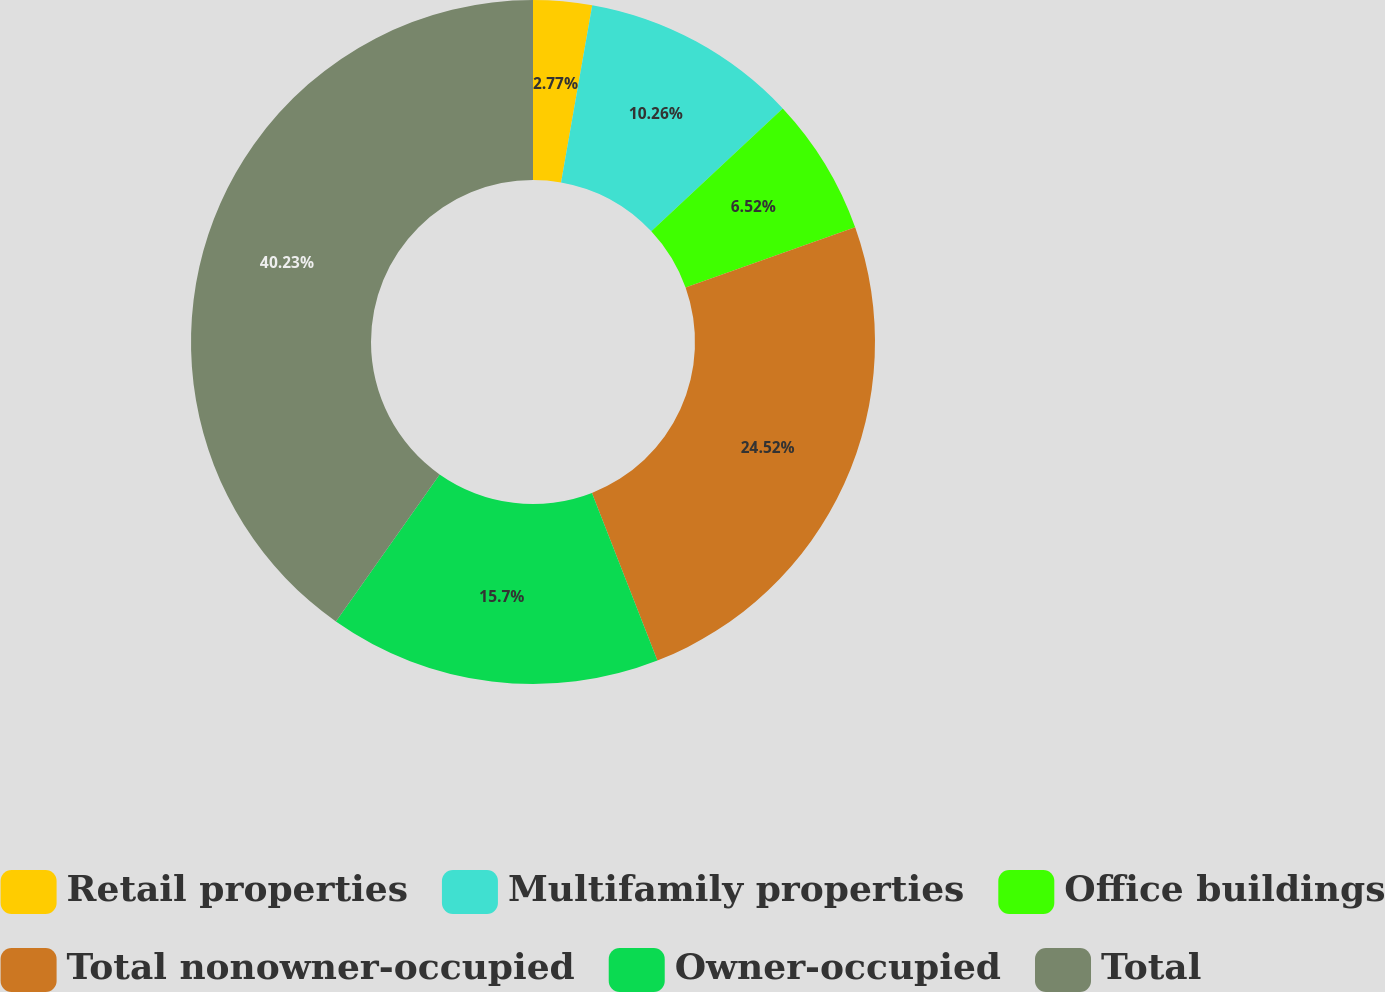<chart> <loc_0><loc_0><loc_500><loc_500><pie_chart><fcel>Retail properties<fcel>Multifamily properties<fcel>Office buildings<fcel>Total nonowner-occupied<fcel>Owner-occupied<fcel>Total<nl><fcel>2.77%<fcel>10.26%<fcel>6.52%<fcel>24.52%<fcel>15.7%<fcel>40.22%<nl></chart> 